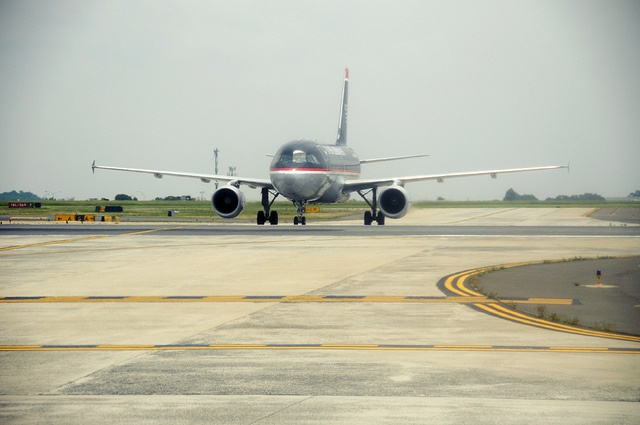Describe the objects in this image and their specific colors. I can see a airplane in gray, darkgray, lightgray, and black tones in this image. 